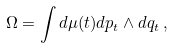Convert formula to latex. <formula><loc_0><loc_0><loc_500><loc_500>\Omega = \int d \mu ( t ) d p _ { t } \wedge d q _ { t } \, ,</formula> 